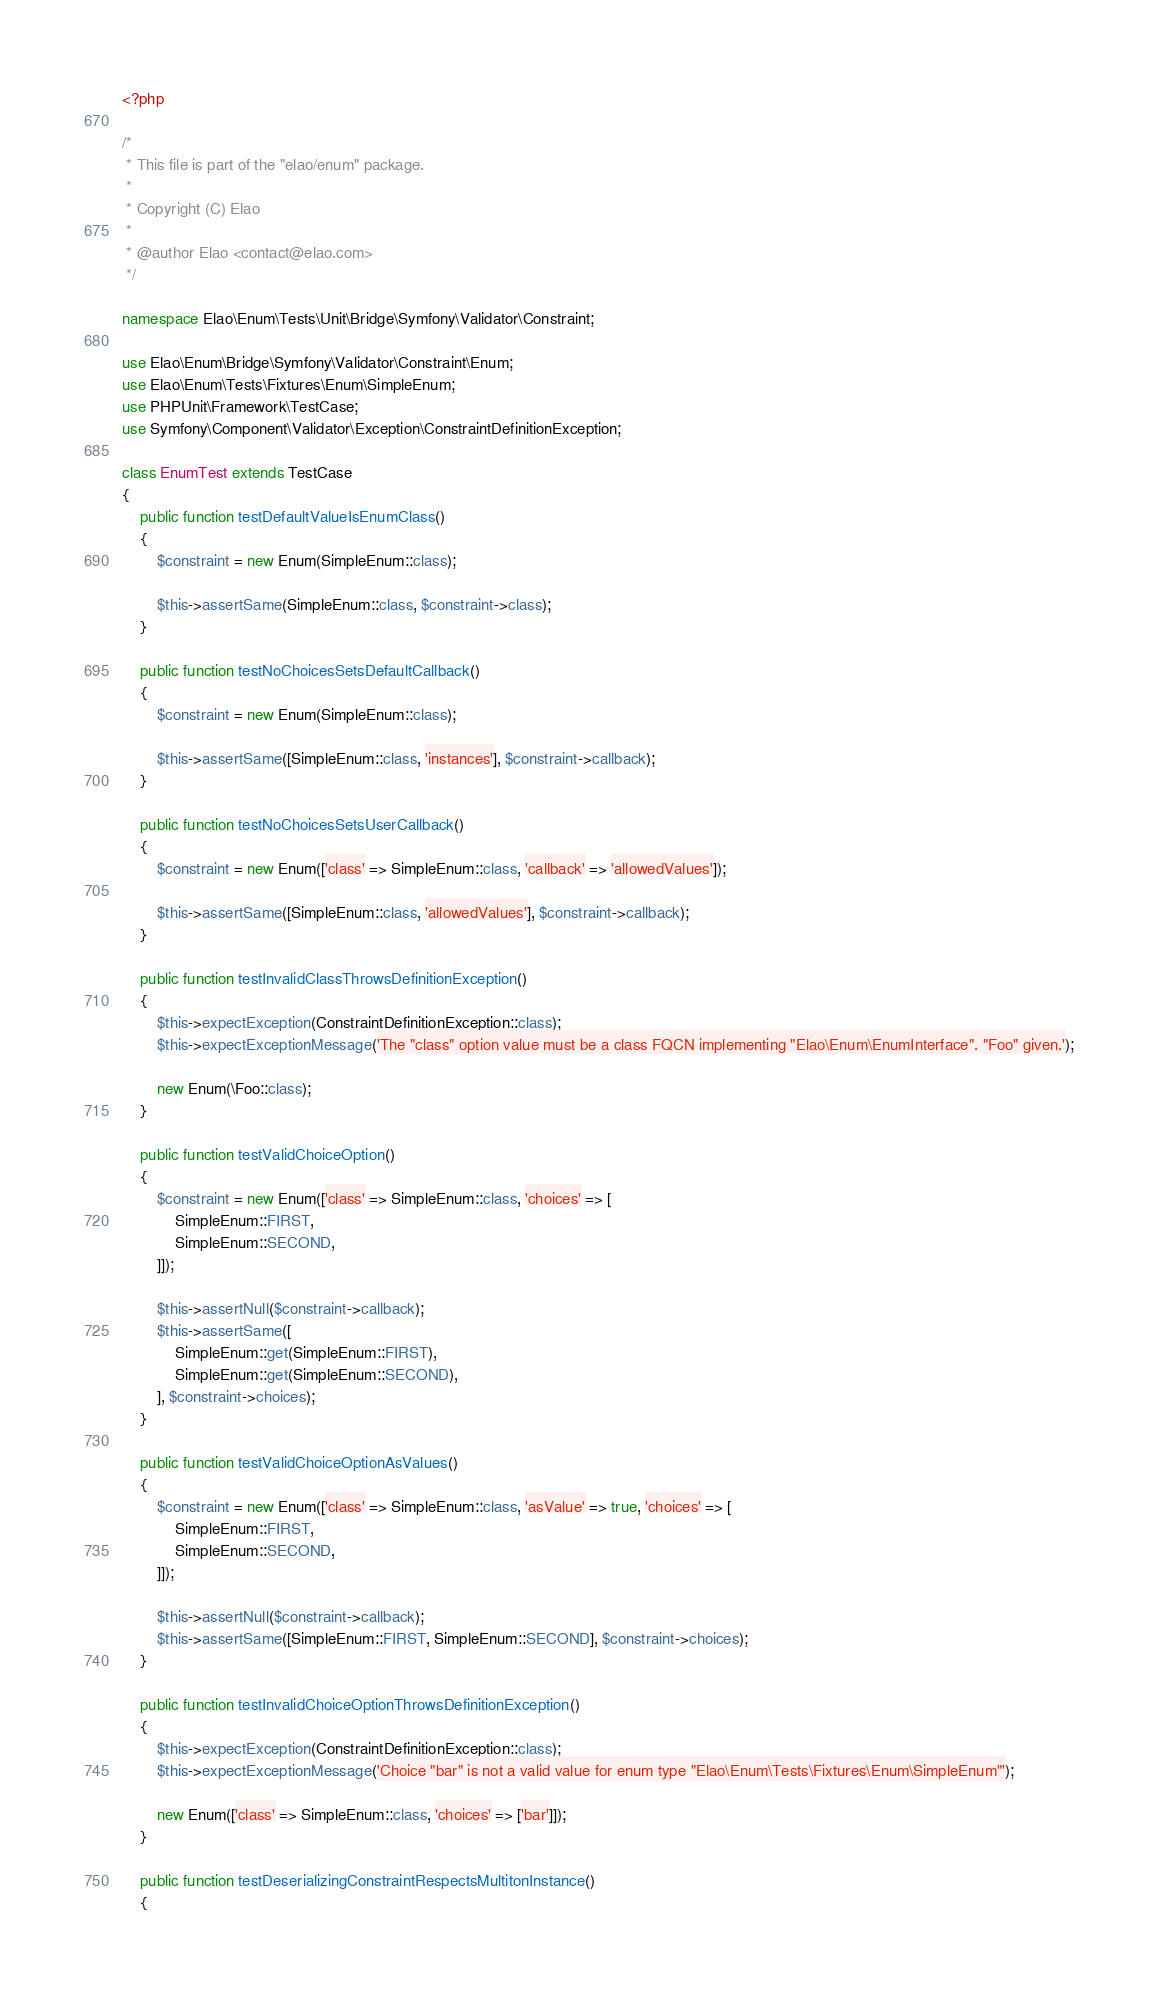<code> <loc_0><loc_0><loc_500><loc_500><_PHP_><?php

/*
 * This file is part of the "elao/enum" package.
 *
 * Copyright (C) Elao
 *
 * @author Elao <contact@elao.com>
 */

namespace Elao\Enum\Tests\Unit\Bridge\Symfony\Validator\Constraint;

use Elao\Enum\Bridge\Symfony\Validator\Constraint\Enum;
use Elao\Enum\Tests\Fixtures\Enum\SimpleEnum;
use PHPUnit\Framework\TestCase;
use Symfony\Component\Validator\Exception\ConstraintDefinitionException;

class EnumTest extends TestCase
{
    public function testDefaultValueIsEnumClass()
    {
        $constraint = new Enum(SimpleEnum::class);

        $this->assertSame(SimpleEnum::class, $constraint->class);
    }

    public function testNoChoicesSetsDefaultCallback()
    {
        $constraint = new Enum(SimpleEnum::class);

        $this->assertSame([SimpleEnum::class, 'instances'], $constraint->callback);
    }

    public function testNoChoicesSetsUserCallback()
    {
        $constraint = new Enum(['class' => SimpleEnum::class, 'callback' => 'allowedValues']);

        $this->assertSame([SimpleEnum::class, 'allowedValues'], $constraint->callback);
    }

    public function testInvalidClassThrowsDefinitionException()
    {
        $this->expectException(ConstraintDefinitionException::class);
        $this->expectExceptionMessage('The "class" option value must be a class FQCN implementing "Elao\Enum\EnumInterface". "Foo" given.');

        new Enum(\Foo::class);
    }

    public function testValidChoiceOption()
    {
        $constraint = new Enum(['class' => SimpleEnum::class, 'choices' => [
            SimpleEnum::FIRST,
            SimpleEnum::SECOND,
        ]]);

        $this->assertNull($constraint->callback);
        $this->assertSame([
            SimpleEnum::get(SimpleEnum::FIRST),
            SimpleEnum::get(SimpleEnum::SECOND),
        ], $constraint->choices);
    }

    public function testValidChoiceOptionAsValues()
    {
        $constraint = new Enum(['class' => SimpleEnum::class, 'asValue' => true, 'choices' => [
            SimpleEnum::FIRST,
            SimpleEnum::SECOND,
        ]]);

        $this->assertNull($constraint->callback);
        $this->assertSame([SimpleEnum::FIRST, SimpleEnum::SECOND], $constraint->choices);
    }

    public function testInvalidChoiceOptionThrowsDefinitionException()
    {
        $this->expectException(ConstraintDefinitionException::class);
        $this->expectExceptionMessage('Choice "bar" is not a valid value for enum type "Elao\Enum\Tests\Fixtures\Enum\SimpleEnum"');

        new Enum(['class' => SimpleEnum::class, 'choices' => ['bar']]);
    }

    public function testDeserializingConstraintRespectsMultitonInstance()
    {</code> 